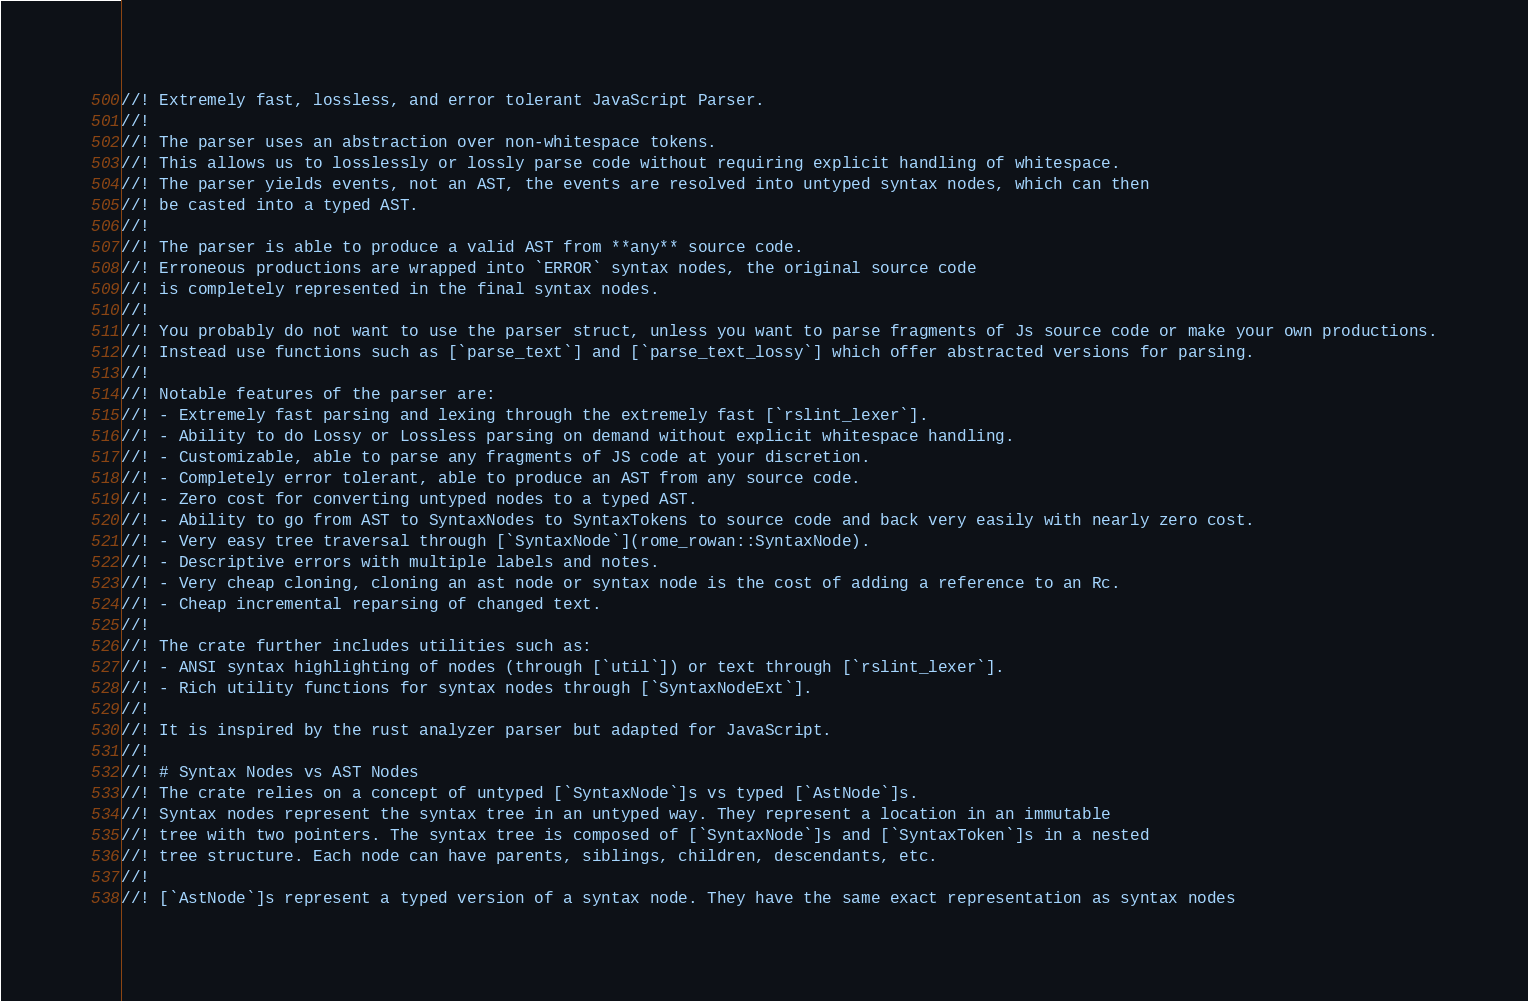<code> <loc_0><loc_0><loc_500><loc_500><_Rust_>//! Extremely fast, lossless, and error tolerant JavaScript Parser.
//!
//! The parser uses an abstraction over non-whitespace tokens.
//! This allows us to losslessly or lossly parse code without requiring explicit handling of whitespace.
//! The parser yields events, not an AST, the events are resolved into untyped syntax nodes, which can then
//! be casted into a typed AST.
//!
//! The parser is able to produce a valid AST from **any** source code.
//! Erroneous productions are wrapped into `ERROR` syntax nodes, the original source code
//! is completely represented in the final syntax nodes.
//!
//! You probably do not want to use the parser struct, unless you want to parse fragments of Js source code or make your own productions.
//! Instead use functions such as [`parse_text`] and [`parse_text_lossy`] which offer abstracted versions for parsing.
//!
//! Notable features of the parser are:
//! - Extremely fast parsing and lexing through the extremely fast [`rslint_lexer`].
//! - Ability to do Lossy or Lossless parsing on demand without explicit whitespace handling.
//! - Customizable, able to parse any fragments of JS code at your discretion.
//! - Completely error tolerant, able to produce an AST from any source code.
//! - Zero cost for converting untyped nodes to a typed AST.
//! - Ability to go from AST to SyntaxNodes to SyntaxTokens to source code and back very easily with nearly zero cost.
//! - Very easy tree traversal through [`SyntaxNode`](rome_rowan::SyntaxNode).
//! - Descriptive errors with multiple labels and notes.
//! - Very cheap cloning, cloning an ast node or syntax node is the cost of adding a reference to an Rc.
//! - Cheap incremental reparsing of changed text.
//!
//! The crate further includes utilities such as:
//! - ANSI syntax highlighting of nodes (through [`util`]) or text through [`rslint_lexer`].
//! - Rich utility functions for syntax nodes through [`SyntaxNodeExt`].
//!
//! It is inspired by the rust analyzer parser but adapted for JavaScript.
//!
//! # Syntax Nodes vs AST Nodes
//! The crate relies on a concept of untyped [`SyntaxNode`]s vs typed [`AstNode`]s.
//! Syntax nodes represent the syntax tree in an untyped way. They represent a location in an immutable
//! tree with two pointers. The syntax tree is composed of [`SyntaxNode`]s and [`SyntaxToken`]s in a nested
//! tree structure. Each node can have parents, siblings, children, descendants, etc.
//!
//! [`AstNode`]s represent a typed version of a syntax node. They have the same exact representation as syntax nodes</code> 